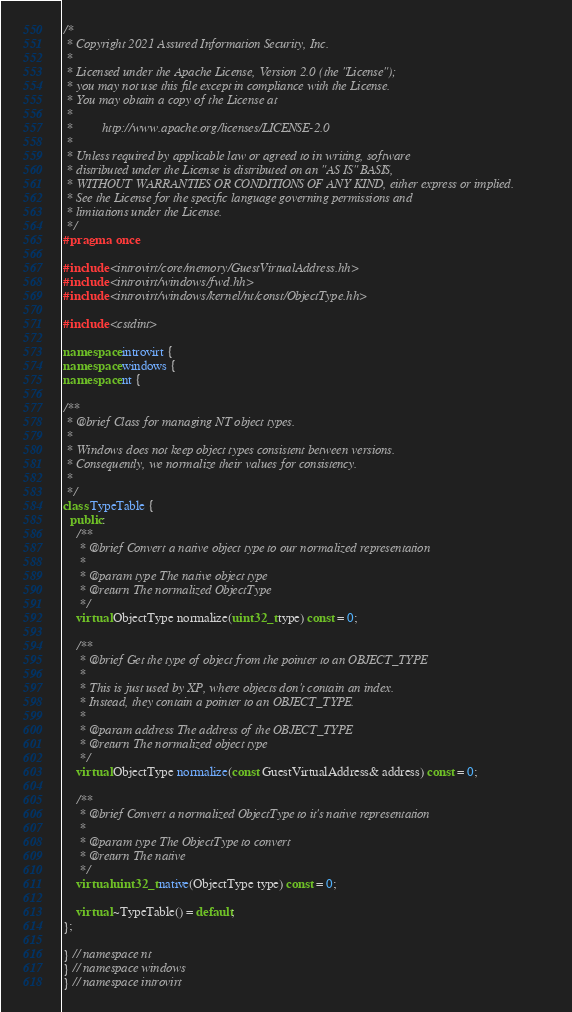<code> <loc_0><loc_0><loc_500><loc_500><_C++_>/*
 * Copyright 2021 Assured Information Security, Inc.
 *
 * Licensed under the Apache License, Version 2.0 (the "License");
 * you may not use this file except in compliance with the License.
 * You may obtain a copy of the License at
 *
 *         http://www.apache.org/licenses/LICENSE-2.0
 *
 * Unless required by applicable law or agreed to in writing, software
 * distributed under the License is distributed on an "AS IS" BASIS,
 * WITHOUT WARRANTIES OR CONDITIONS OF ANY KIND, either express or implied.
 * See the License for the specific language governing permissions and
 * limitations under the License.
 */
#pragma once

#include <introvirt/core/memory/GuestVirtualAddress.hh>
#include <introvirt/windows/fwd.hh>
#include <introvirt/windows/kernel/nt/const/ObjectType.hh>

#include <cstdint>

namespace introvirt {
namespace windows {
namespace nt {

/**
 * @brief Class for managing NT object types.
 *
 * Windows does not keep object types consistent between versions.
 * Consequently, we normalize their values for consistency.
 *
 */
class TypeTable {
  public:
    /**
     * @brief Convert a native object type to our normalized representation
     *
     * @param type The native object type
     * @return The normalized ObjectType
     */
    virtual ObjectType normalize(uint32_t type) const = 0;

    /**
     * @brief Get the type of object from the pointer to an OBJECT_TYPE
     *
     * This is just used by XP, where objects don't contain an index.
     * Instead, they contain a pointer to an OBJECT_TYPE.
     *
     * @param address The address of the OBJECT_TYPE
     * @return The normalized object type
     */
    virtual ObjectType normalize(const GuestVirtualAddress& address) const = 0;

    /**
     * @brief Convert a normalized ObjectType to it's native representation
     *
     * @param type The ObjectType to convert
     * @return The native
     */
    virtual uint32_t native(ObjectType type) const = 0;

    virtual ~TypeTable() = default;
};

} // namespace nt
} // namespace windows
} // namespace introvirt</code> 